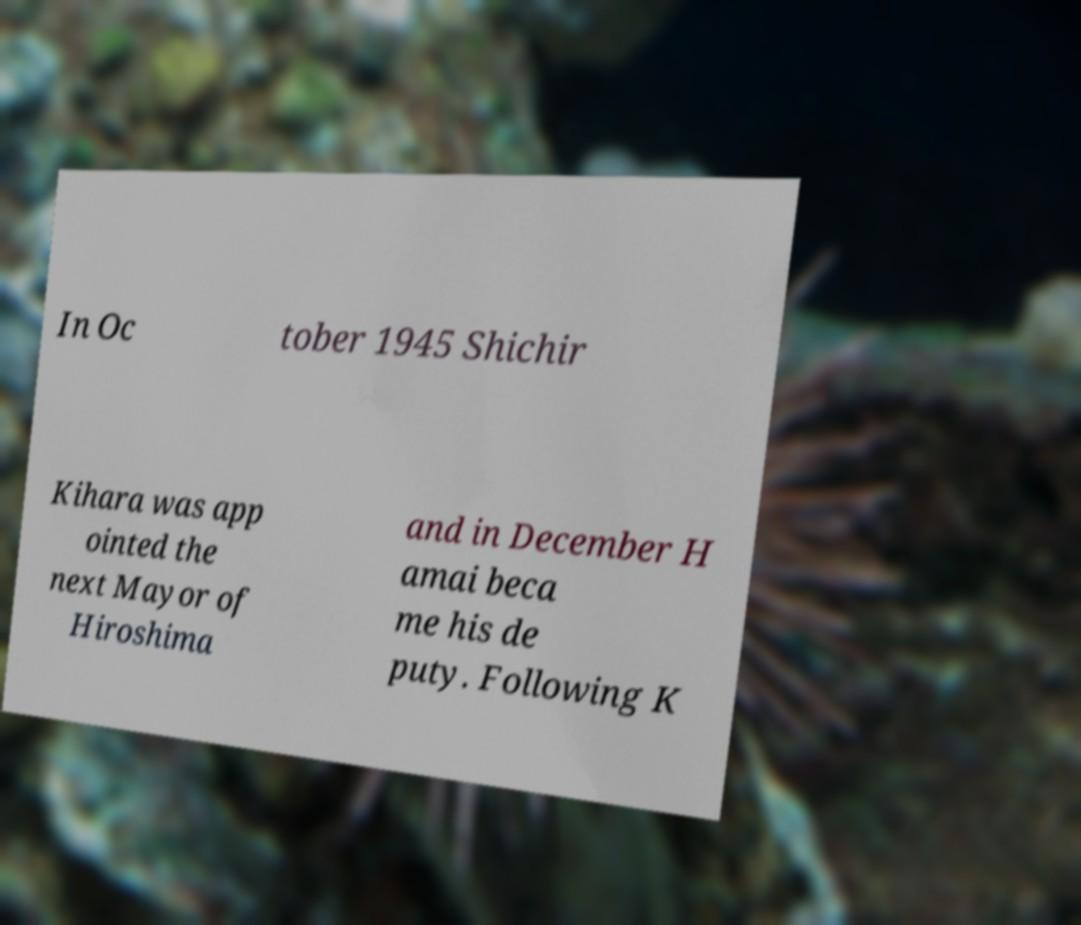There's text embedded in this image that I need extracted. Can you transcribe it verbatim? In Oc tober 1945 Shichir Kihara was app ointed the next Mayor of Hiroshima and in December H amai beca me his de puty. Following K 